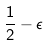<formula> <loc_0><loc_0><loc_500><loc_500>\frac { 1 } { 2 } - \epsilon</formula> 